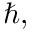<formula> <loc_0><loc_0><loc_500><loc_500>\hbar { , }</formula> 